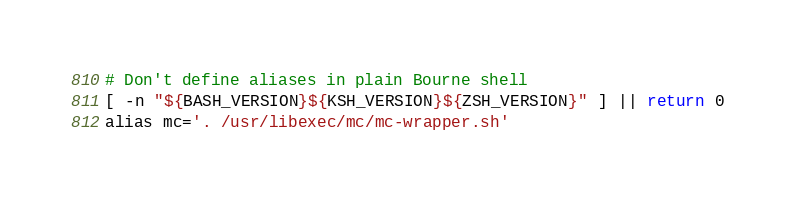<code> <loc_0><loc_0><loc_500><loc_500><_Bash_># Don't define aliases in plain Bourne shell
[ -n "${BASH_VERSION}${KSH_VERSION}${ZSH_VERSION}" ] || return 0
alias mc='. /usr/libexec/mc/mc-wrapper.sh'
</code> 